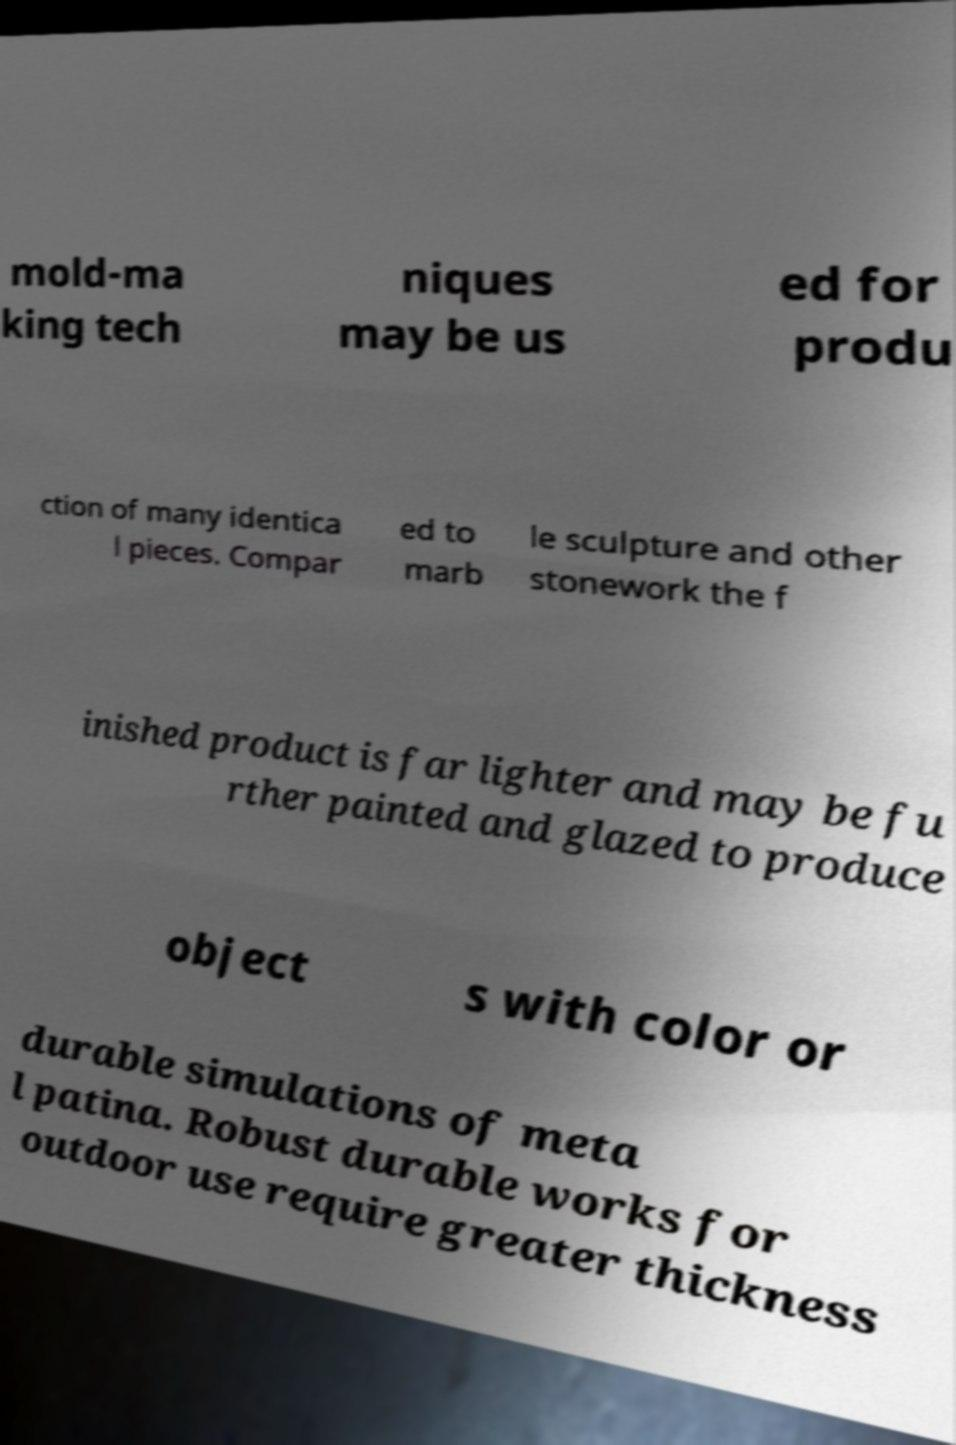Can you accurately transcribe the text from the provided image for me? mold-ma king tech niques may be us ed for produ ction of many identica l pieces. Compar ed to marb le sculpture and other stonework the f inished product is far lighter and may be fu rther painted and glazed to produce object s with color or durable simulations of meta l patina. Robust durable works for outdoor use require greater thickness 